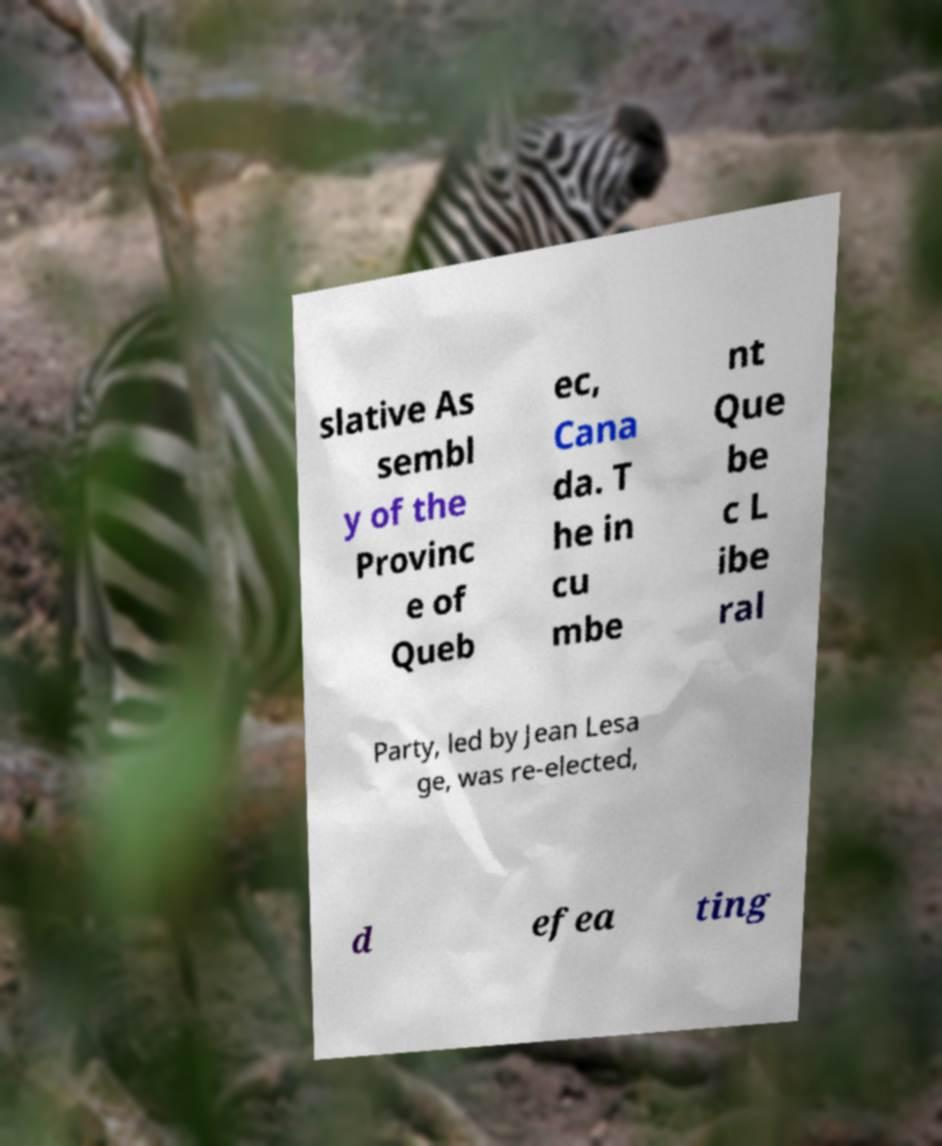I need the written content from this picture converted into text. Can you do that? slative As sembl y of the Provinc e of Queb ec, Cana da. T he in cu mbe nt Que be c L ibe ral Party, led by Jean Lesa ge, was re-elected, d efea ting 